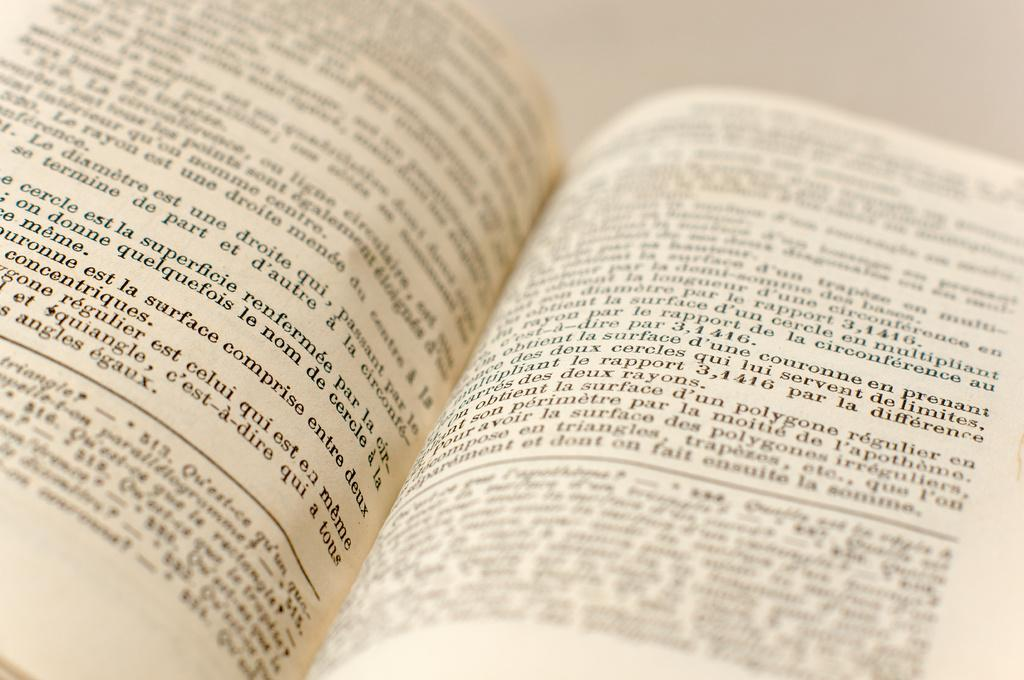<image>
Summarize the visual content of the image. An open book shows the number 513 as part of the footnote on the left page. 